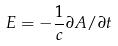<formula> <loc_0><loc_0><loc_500><loc_500>E = - \frac { 1 } { c } \partial A / \partial t</formula> 